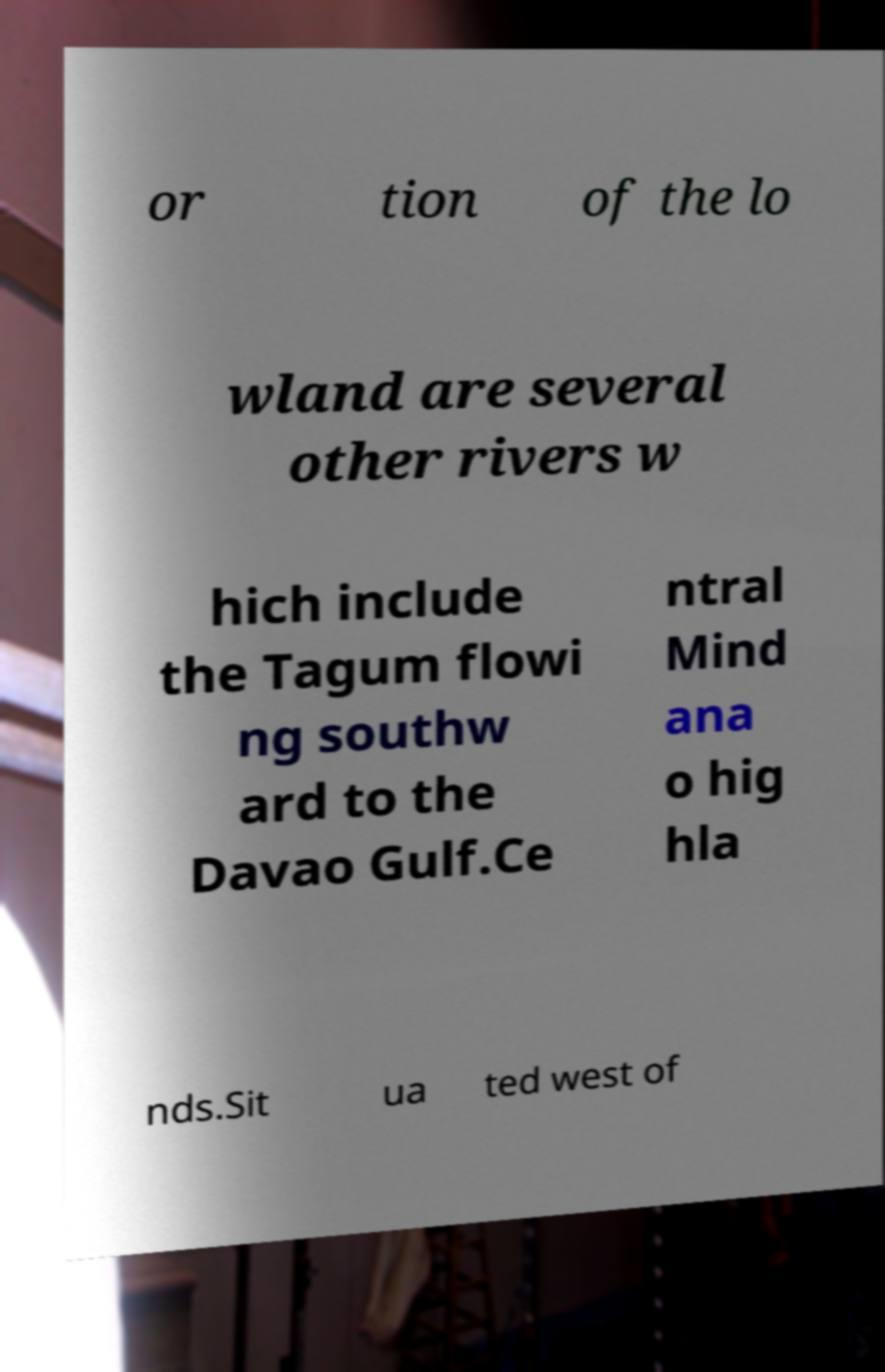Please identify and transcribe the text found in this image. or tion of the lo wland are several other rivers w hich include the Tagum flowi ng southw ard to the Davao Gulf.Ce ntral Mind ana o hig hla nds.Sit ua ted west of 